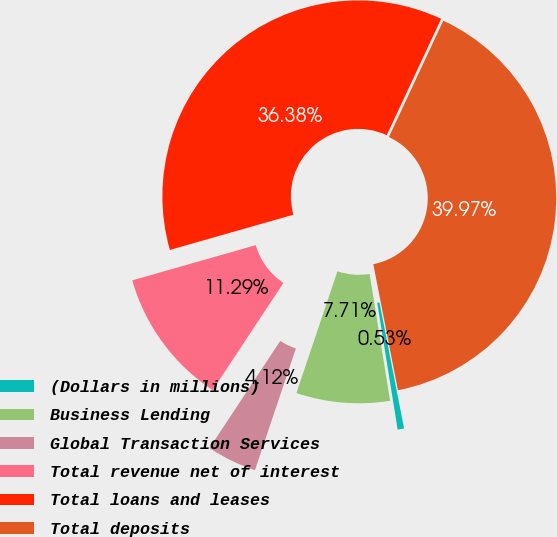Convert chart. <chart><loc_0><loc_0><loc_500><loc_500><pie_chart><fcel>(Dollars in millions)<fcel>Business Lending<fcel>Global Transaction Services<fcel>Total revenue net of interest<fcel>Total loans and leases<fcel>Total deposits<nl><fcel>0.53%<fcel>7.71%<fcel>4.12%<fcel>11.29%<fcel>36.38%<fcel>39.97%<nl></chart> 